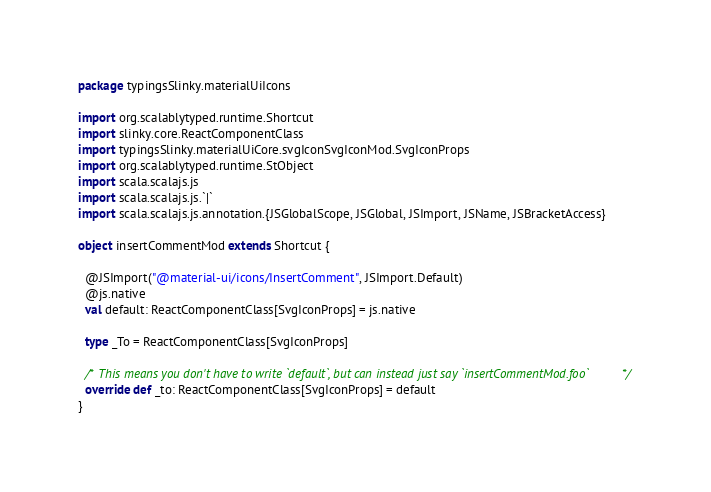<code> <loc_0><loc_0><loc_500><loc_500><_Scala_>package typingsSlinky.materialUiIcons

import org.scalablytyped.runtime.Shortcut
import slinky.core.ReactComponentClass
import typingsSlinky.materialUiCore.svgIconSvgIconMod.SvgIconProps
import org.scalablytyped.runtime.StObject
import scala.scalajs.js
import scala.scalajs.js.`|`
import scala.scalajs.js.annotation.{JSGlobalScope, JSGlobal, JSImport, JSName, JSBracketAccess}

object insertCommentMod extends Shortcut {
  
  @JSImport("@material-ui/icons/InsertComment", JSImport.Default)
  @js.native
  val default: ReactComponentClass[SvgIconProps] = js.native
  
  type _To = ReactComponentClass[SvgIconProps]
  
  /* This means you don't have to write `default`, but can instead just say `insertCommentMod.foo` */
  override def _to: ReactComponentClass[SvgIconProps] = default
}
</code> 